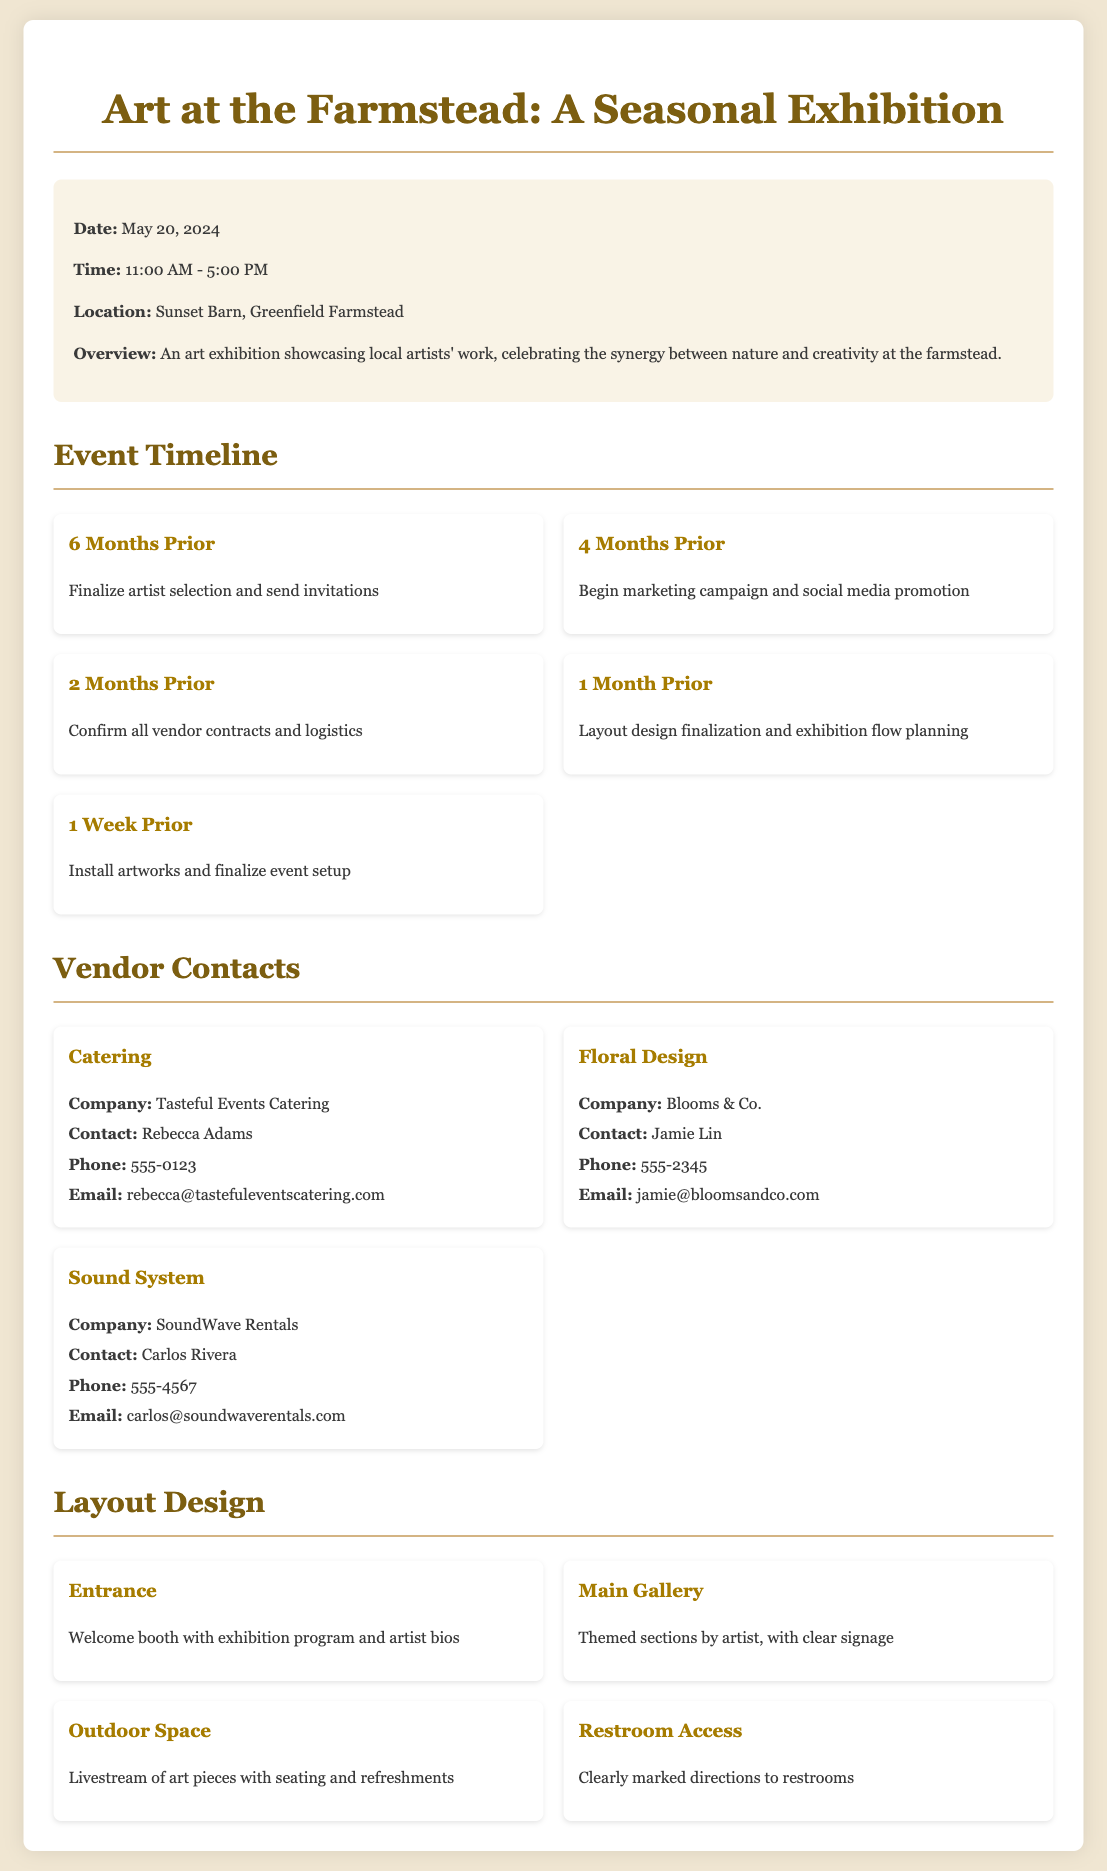what is the date of the event? The date of the event is specified in the document under event details.
Answer: May 20, 2024 what time does the event start? The start time is mentioned in the event details section.
Answer: 11:00 AM who is the contact person for catering? The contact person for catering is listed in the vendor contacts section.
Answer: Rebecca Adams how many months prior should artist selection be finalized? This detail is provided in the timeline section of the document.
Answer: 6 Months what is the name of the floral design company? The name of the floral design company can be found in the vendor contacts section.
Answer: Blooms & Co what section of the layout includes a welcome booth? This information is detailed in the layout design section.
Answer: Entrance how many vendors are listed in the document? The document specifies the number of vendors in the vendor contacts section.
Answer: 3 what is the theme of the main gallery? The theme information can be found within the layout design description.
Answer: Themed sections by artist what is the purpose of the outdoor space in the layout? The outdoor space's purpose is mentioned in the layout design section.
Answer: Livestream of art pieces with seating and refreshments 